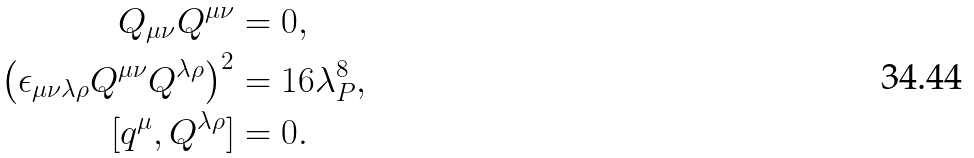<formula> <loc_0><loc_0><loc_500><loc_500>Q _ { \mu \nu } Q ^ { \mu \nu } & = 0 , \\ \left ( \epsilon _ { \mu \nu \lambda \rho } Q ^ { \mu \nu } Q ^ { \lambda \rho } \right ) ^ { 2 } & = 1 6 \lambda _ { P } ^ { 8 } , \\ [ q ^ { \mu } , Q ^ { \lambda \rho } ] & = 0 .</formula> 